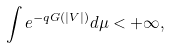<formula> <loc_0><loc_0><loc_500><loc_500>\int e ^ { - q G ( | V | ) } d \mu < + \infty ,</formula> 